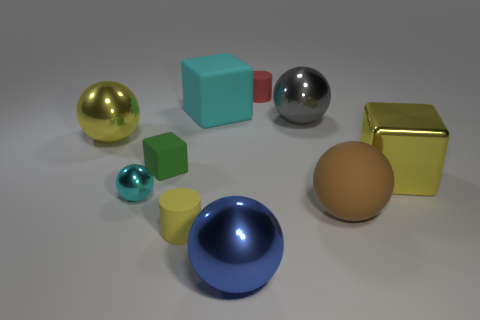Is there a tiny ball?
Provide a succinct answer. Yes. Do the yellow sphere and the cube that is behind the green matte object have the same material?
Offer a terse response. No. What material is the cyan sphere that is the same size as the green object?
Offer a very short reply. Metal. Are there any tiny things that have the same material as the big yellow cube?
Provide a short and direct response. Yes. Is there a yellow block in front of the large sphere that is in front of the small matte cylinder in front of the tiny rubber block?
Your response must be concise. No. What shape is the shiny thing that is the same size as the green matte block?
Your response must be concise. Sphere. There is a yellow metallic object left of the big gray thing; is it the same size as the cylinder that is behind the brown thing?
Your answer should be very brief. No. How many yellow cylinders are there?
Keep it short and to the point. 1. There is a rubber block in front of the yellow shiny object to the left of the rubber cylinder in front of the large gray thing; what is its size?
Offer a very short reply. Small. Is the color of the large rubber ball the same as the tiny metal sphere?
Give a very brief answer. No. 